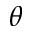Convert formula to latex. <formula><loc_0><loc_0><loc_500><loc_500>\theta</formula> 